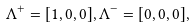<formula> <loc_0><loc_0><loc_500><loc_500>\Lambda ^ { + } = [ 1 , 0 , 0 ] , \Lambda ^ { - } = [ 0 , 0 , 0 ] ,</formula> 